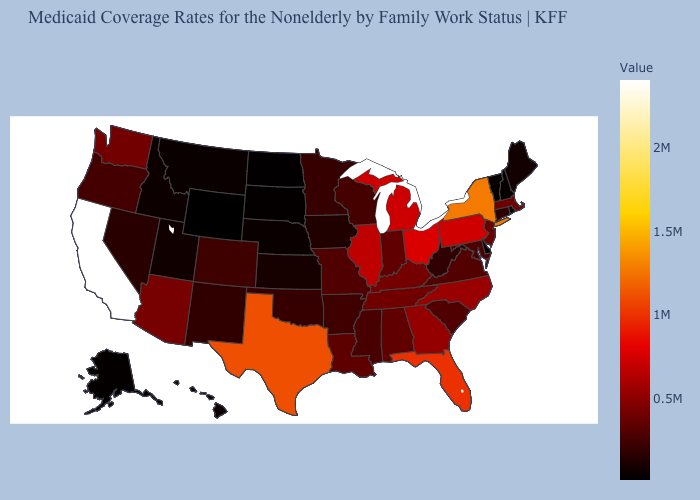Does Wisconsin have the lowest value in the MidWest?
Concise answer only. No. 